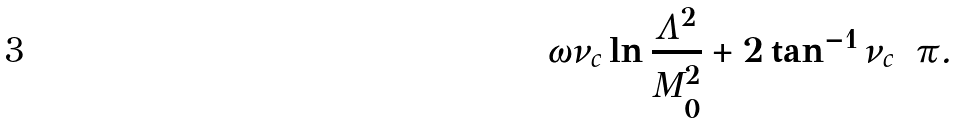<formula> <loc_0><loc_0><loc_500><loc_500>\omega \nu _ { c } \ln \frac { \Lambda ^ { 2 } } { M _ { 0 } ^ { 2 } } + 2 \tan ^ { - 1 } \nu _ { c } = \pi .</formula> 